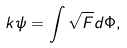<formula> <loc_0><loc_0><loc_500><loc_500>k \psi = \int \sqrt { F } d \Phi ,</formula> 